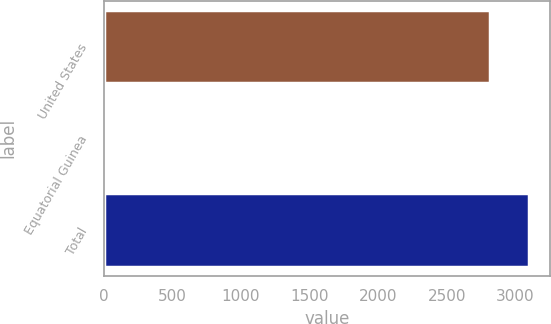Convert chart. <chart><loc_0><loc_0><loc_500><loc_500><bar_chart><fcel>United States<fcel>Equatorial Guinea<fcel>Total<nl><fcel>2816<fcel>8<fcel>3097.9<nl></chart> 